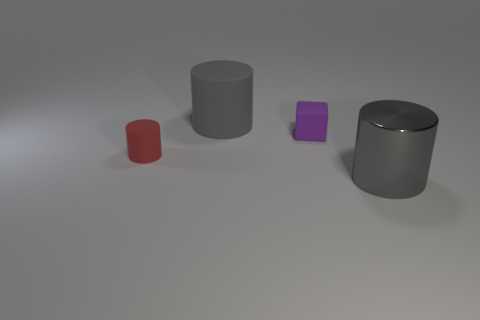Subtract all tiny red matte cylinders. How many cylinders are left? 2 Add 1 large cylinders. How many objects exist? 5 Subtract all red cylinders. How many cylinders are left? 2 Subtract all cylinders. How many objects are left? 1 Subtract all cyan spheres. How many gray cylinders are left? 2 Add 1 red rubber cylinders. How many red rubber cylinders are left? 2 Add 4 purple rubber objects. How many purple rubber objects exist? 5 Subtract 0 green balls. How many objects are left? 4 Subtract 1 cylinders. How many cylinders are left? 2 Subtract all cyan blocks. Subtract all gray balls. How many blocks are left? 1 